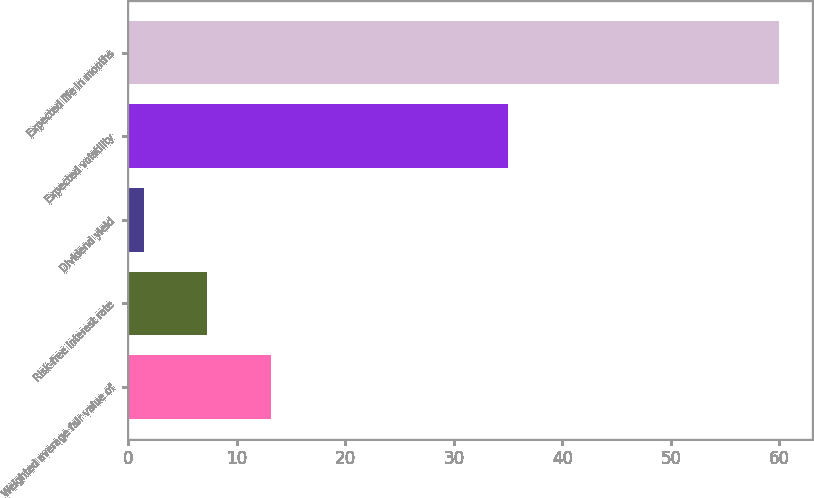Convert chart to OTSL. <chart><loc_0><loc_0><loc_500><loc_500><bar_chart><fcel>Weighted average fair value of<fcel>Risk-free interest rate<fcel>Dividend yield<fcel>Expected volatility<fcel>Expected life in months<nl><fcel>13.12<fcel>7.26<fcel>1.4<fcel>35<fcel>60<nl></chart> 